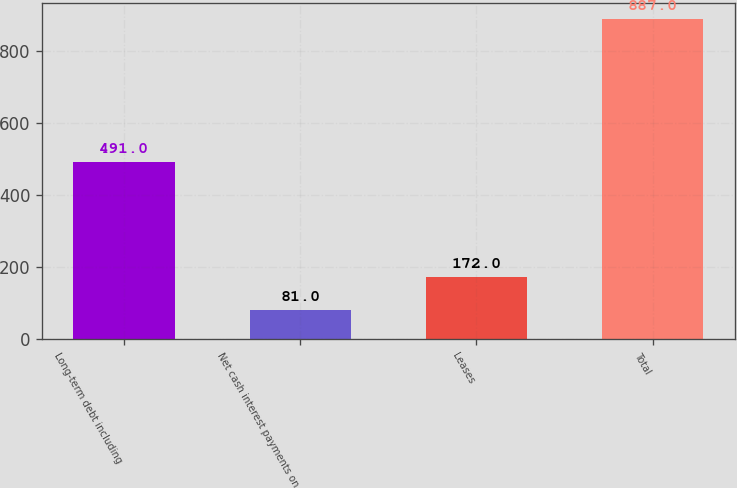<chart> <loc_0><loc_0><loc_500><loc_500><bar_chart><fcel>Long-term debt including<fcel>Net cash interest payments on<fcel>Leases<fcel>Total<nl><fcel>491<fcel>81<fcel>172<fcel>887<nl></chart> 